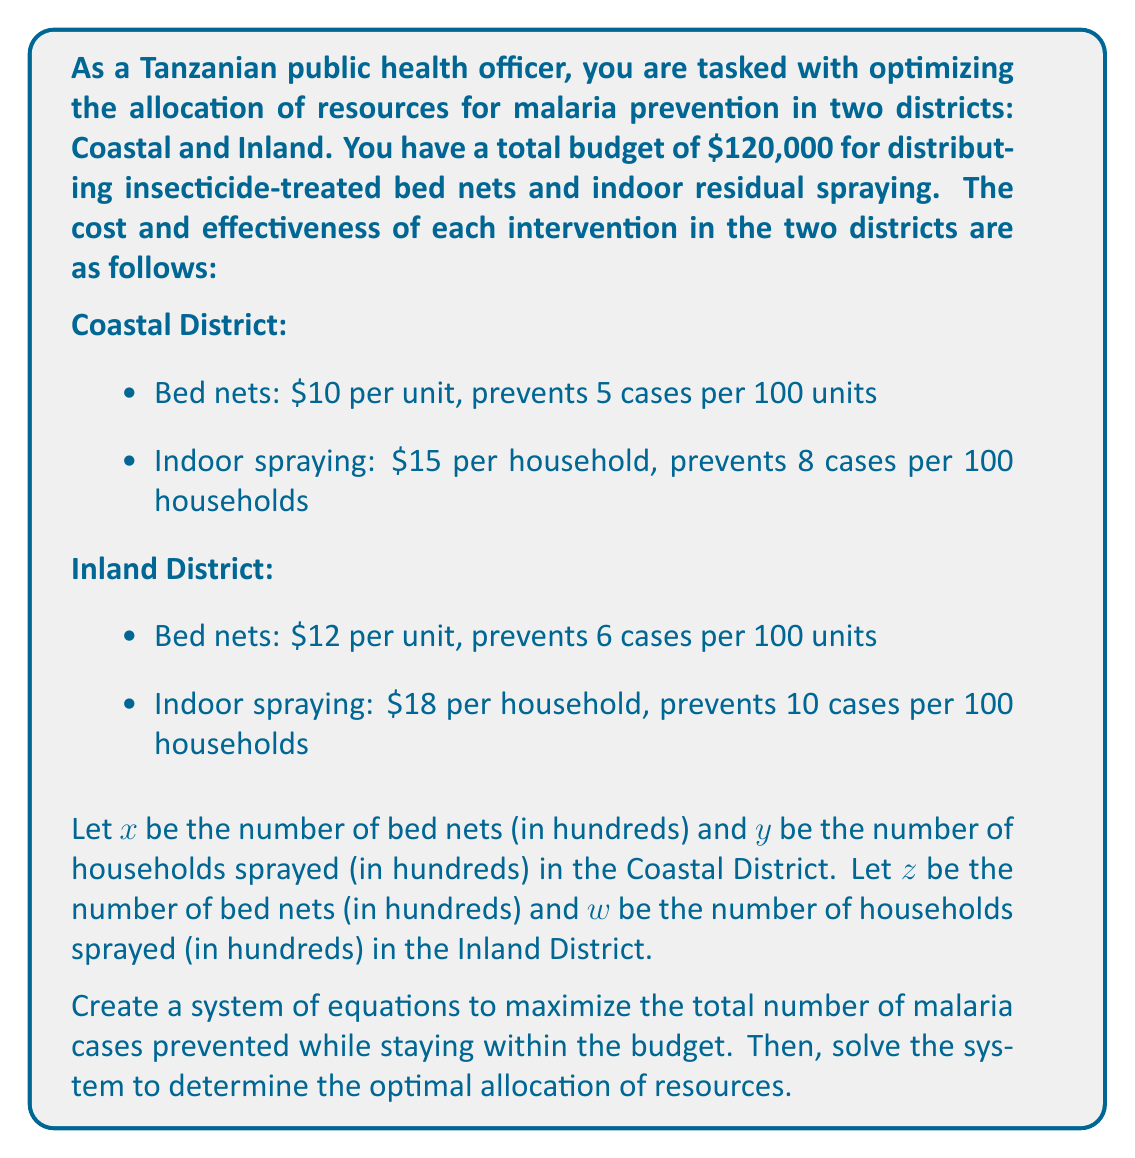Help me with this question. To solve this problem, we need to set up a system of equations and then maximize the objective function. Let's break it down step by step:

1. Budget constraint equation:
   $$(10x + 15y) + (12z + 18w) = 1200$$
   (Note: We multiplied the budget by 10 to work with hundreds of units)

2. Objective function (total cases prevented):
   $$f(x,y,z,w) = 5x + 8y + 6z + 10w$$

Now, we need to maximize $f(x,y,z,w)$ subject to the budget constraint. To do this, we can use the method of Lagrange multipliers:

3. Set up the Lagrangian function:
   $$L(x,y,z,w,\lambda) = 5x + 8y + 6z + 10w - \lambda(10x + 15y + 12z + 18w - 1200)$$

4. Take partial derivatives and set them equal to zero:
   $$\frac{\partial L}{\partial x} = 5 - 10\lambda = 0$$
   $$\frac{\partial L}{\partial y} = 8 - 15\lambda = 0$$
   $$\frac{\partial L}{\partial z} = 6 - 12\lambda = 0$$
   $$\frac{\partial L}{\partial w} = 10 - 18\lambda = 0$$
   $$\frac{\partial L}{\partial \lambda} = 10x + 15y + 12z + 18w - 1200 = 0$$

5. From these equations, we can deduce:
   $$\lambda = \frac{5}{10} = \frac{8}{15} = \frac{6}{12} = \frac{10}{18} = \frac{5}{9}$$

This implies that the optimal solution is to allocate all resources to indoor spraying in the Inland District, as it has the highest effectiveness-to-cost ratio.

6. Solve for $w$ using the budget constraint:
   $$18w = 1200$$
   $$w = \frac{1200}{18} = 66.67$$

Therefore, the optimal allocation is to spray 6,667 households in the Inland District.
Answer: The optimal allocation of resources is to focus entirely on indoor residual spraying in the Inland District, treating 6,667 households. This will prevent approximately 667 malaria cases (10 cases per 100 households * 66.67 hundreds of households). 